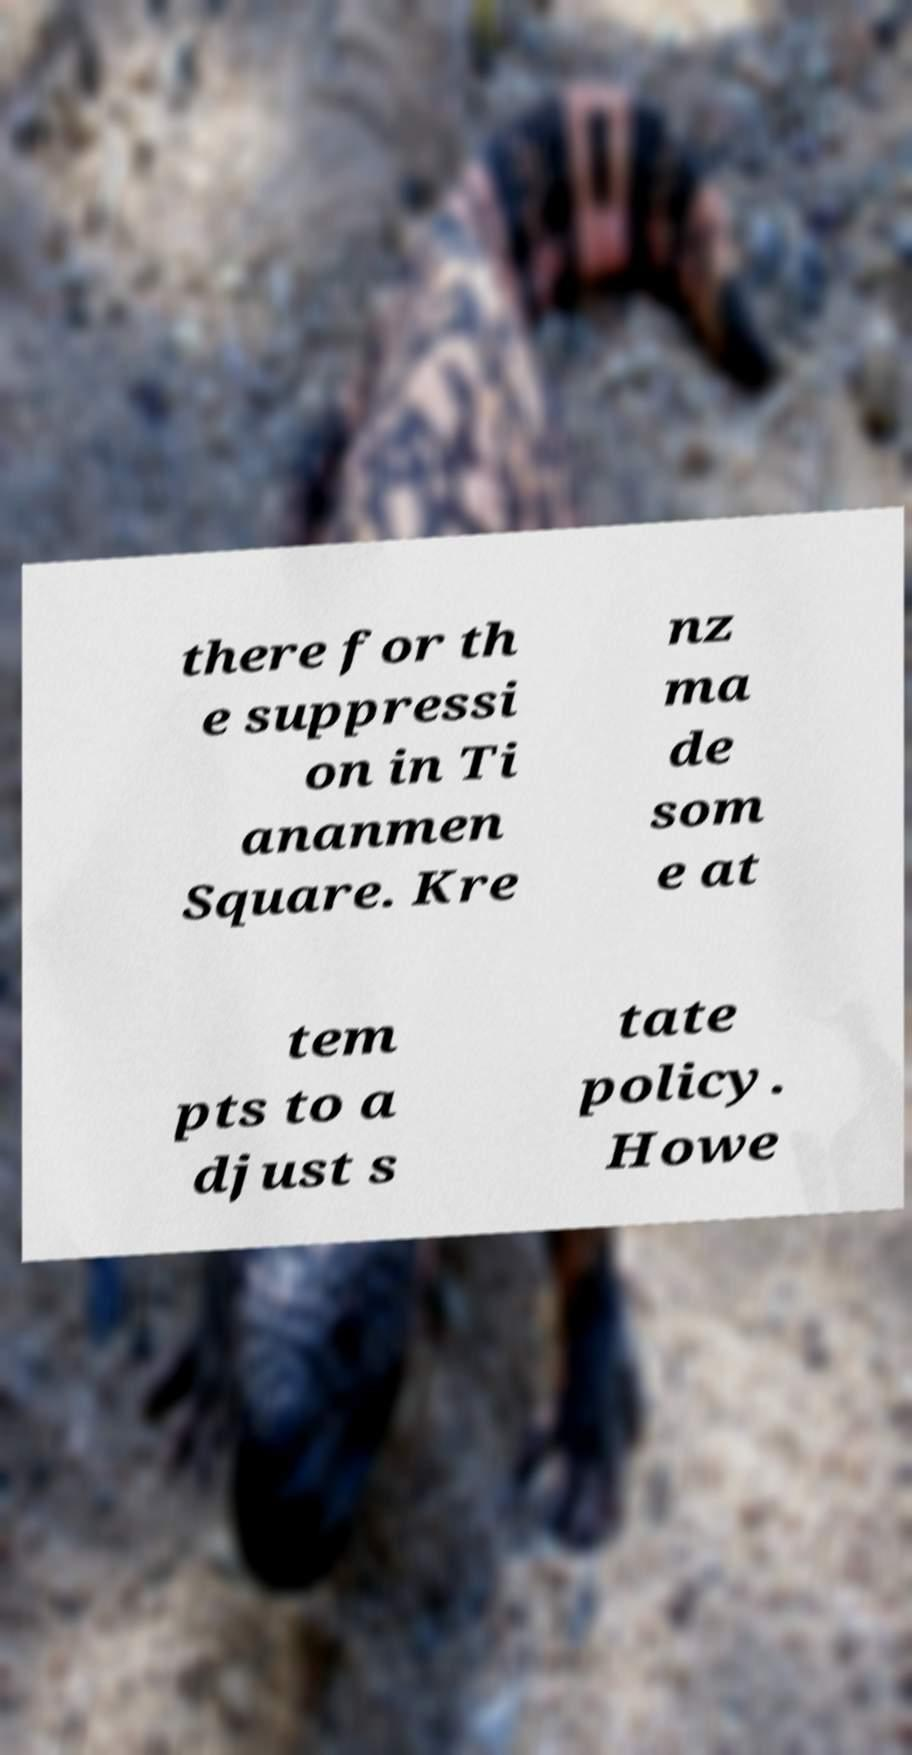Can you accurately transcribe the text from the provided image for me? there for th e suppressi on in Ti ananmen Square. Kre nz ma de som e at tem pts to a djust s tate policy. Howe 